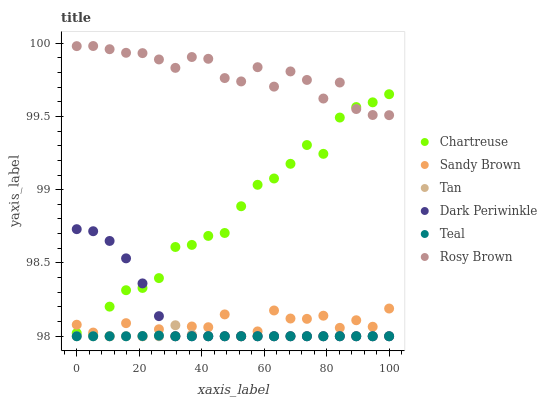Does Teal have the minimum area under the curve?
Answer yes or no. Yes. Does Rosy Brown have the maximum area under the curve?
Answer yes or no. Yes. Does Chartreuse have the minimum area under the curve?
Answer yes or no. No. Does Chartreuse have the maximum area under the curve?
Answer yes or no. No. Is Teal the smoothest?
Answer yes or no. Yes. Is Sandy Brown the roughest?
Answer yes or no. Yes. Is Chartreuse the smoothest?
Answer yes or no. No. Is Chartreuse the roughest?
Answer yes or no. No. Does Teal have the lowest value?
Answer yes or no. Yes. Does Chartreuse have the lowest value?
Answer yes or no. No. Does Rosy Brown have the highest value?
Answer yes or no. Yes. Does Chartreuse have the highest value?
Answer yes or no. No. Is Teal less than Rosy Brown?
Answer yes or no. Yes. Is Rosy Brown greater than Sandy Brown?
Answer yes or no. Yes. Does Tan intersect Teal?
Answer yes or no. Yes. Is Tan less than Teal?
Answer yes or no. No. Is Tan greater than Teal?
Answer yes or no. No. Does Teal intersect Rosy Brown?
Answer yes or no. No. 